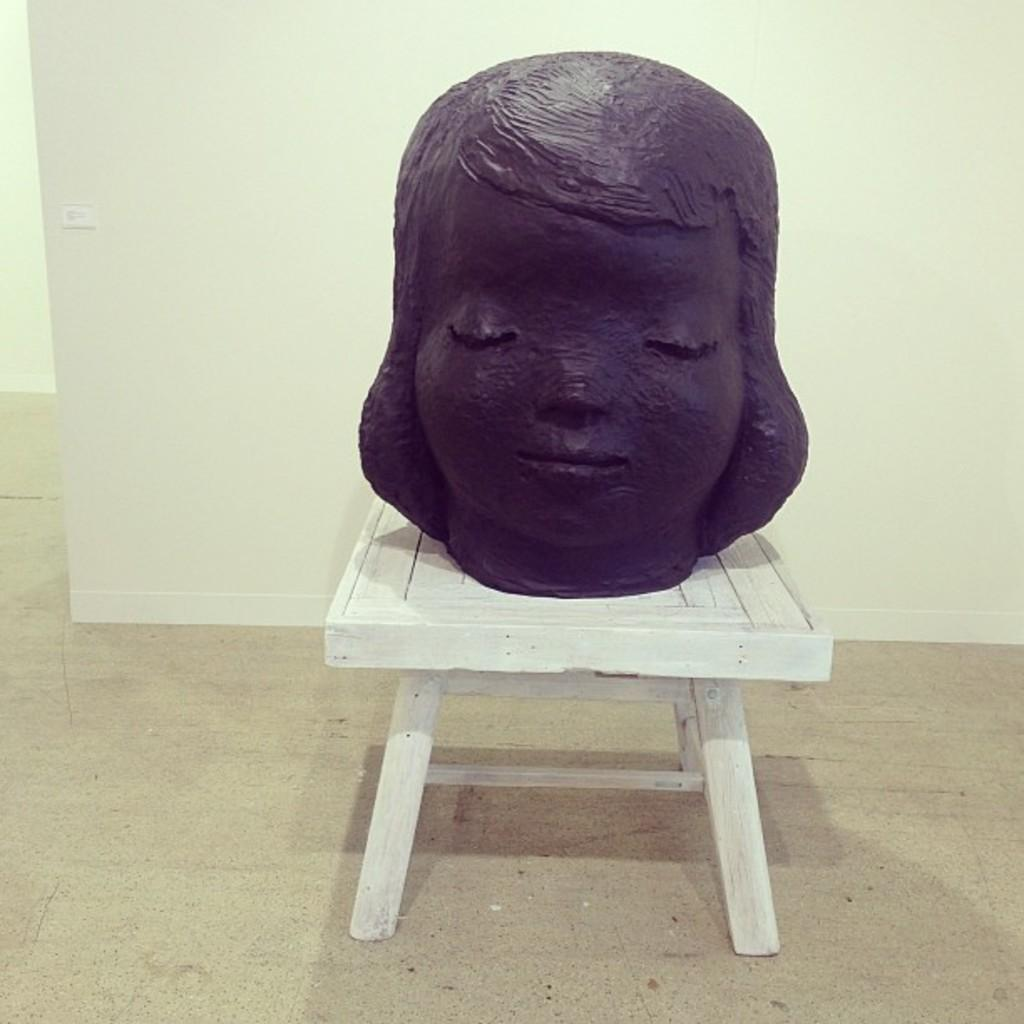What is the main subject of the image? There is a sculpture of a girl in the image. How is the sculpture positioned in the image? The sculpture is placed on a stool. What can be seen in the background of the image? There is a wall in the background of the image. What type of mint is growing on the wall in the image? There is no mint growing on the wall in the image; the wall is simply a part of the background. 